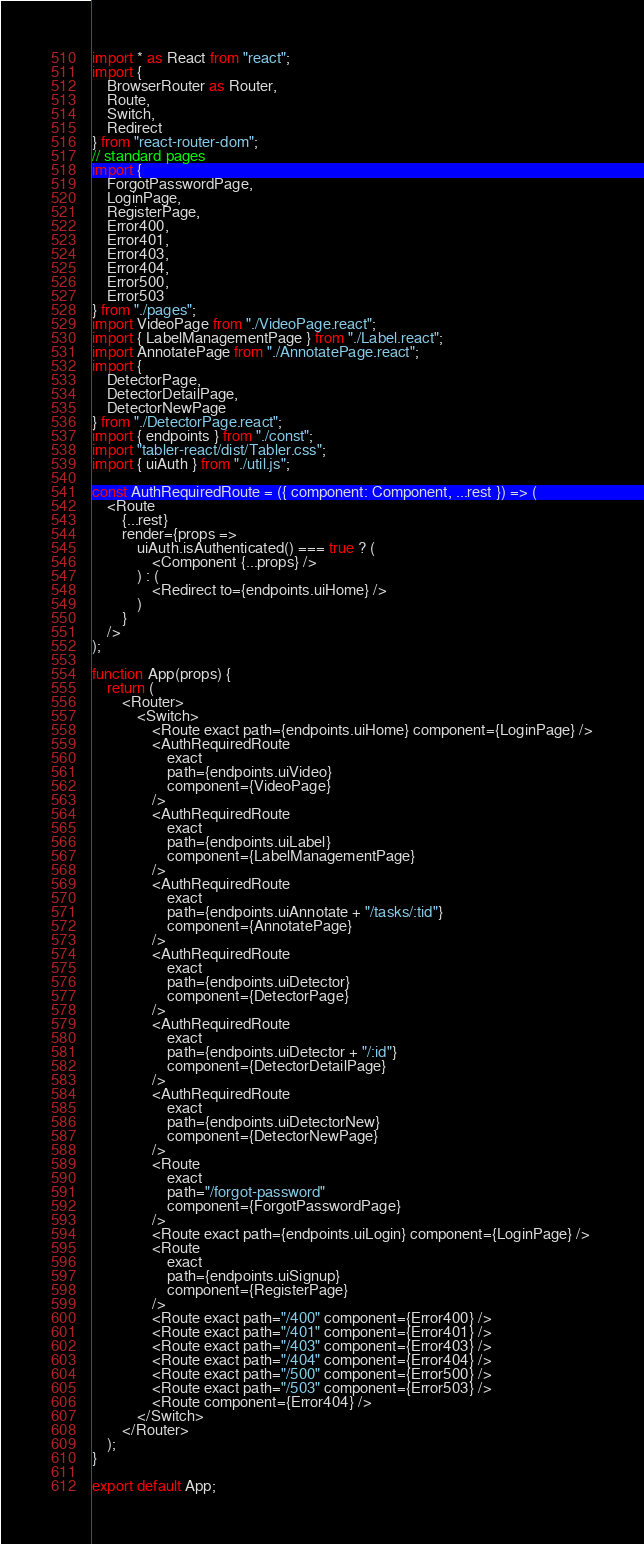Convert code to text. <code><loc_0><loc_0><loc_500><loc_500><_JavaScript_>import * as React from "react";
import {
    BrowserRouter as Router,
    Route,
    Switch,
    Redirect
} from "react-router-dom";
// standard pages
import {
    ForgotPasswordPage,
    LoginPage,
    RegisterPage,
    Error400,
    Error401,
    Error403,
    Error404,
    Error500,
    Error503
} from "./pages";
import VideoPage from "./VideoPage.react";
import { LabelManagementPage } from "./Label.react";
import AnnotatePage from "./AnnotatePage.react";
import {
    DetectorPage,
    DetectorDetailPage,
    DetectorNewPage
} from "./DetectorPage.react";
import { endpoints } from "./const";
import "tabler-react/dist/Tabler.css";
import { uiAuth } from "./util.js";

const AuthRequiredRoute = ({ component: Component, ...rest }) => (
    <Route
        {...rest}
        render={props =>
            uiAuth.isAuthenticated() === true ? (
                <Component {...props} />
            ) : (
                <Redirect to={endpoints.uiHome} />
            )
        }
    />
);

function App(props) {
    return (
        <Router>
            <Switch>
                <Route exact path={endpoints.uiHome} component={LoginPage} />
                <AuthRequiredRoute
                    exact
                    path={endpoints.uiVideo}
                    component={VideoPage}
                />
                <AuthRequiredRoute
                    exact
                    path={endpoints.uiLabel}
                    component={LabelManagementPage}
                />
                <AuthRequiredRoute
                    exact
                    path={endpoints.uiAnnotate + "/tasks/:tid"}
                    component={AnnotatePage}
                />
                <AuthRequiredRoute
                    exact
                    path={endpoints.uiDetector}
                    component={DetectorPage}
                />
                <AuthRequiredRoute
                    exact
                    path={endpoints.uiDetector + "/:id"}
                    component={DetectorDetailPage}
                />
                <AuthRequiredRoute
                    exact
                    path={endpoints.uiDetectorNew}
                    component={DetectorNewPage}
                />
                <Route
                    exact
                    path="/forgot-password"
                    component={ForgotPasswordPage}
                />
                <Route exact path={endpoints.uiLogin} component={LoginPage} />
                <Route
                    exact
                    path={endpoints.uiSignup}
                    component={RegisterPage}
                />
                <Route exact path="/400" component={Error400} />
                <Route exact path="/401" component={Error401} />
                <Route exact path="/403" component={Error403} />
                <Route exact path="/404" component={Error404} />
                <Route exact path="/500" component={Error500} />
                <Route exact path="/503" component={Error503} />
                <Route component={Error404} />
            </Switch>
        </Router>
    );
}

export default App;
</code> 